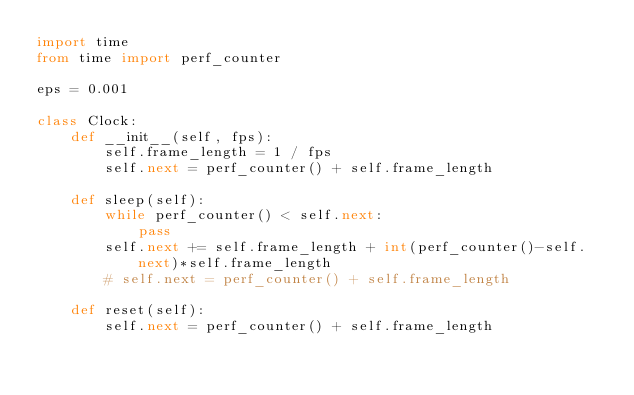Convert code to text. <code><loc_0><loc_0><loc_500><loc_500><_Python_>import time
from time import perf_counter

eps = 0.001

class Clock:
    def __init__(self, fps):
        self.frame_length = 1 / fps
        self.next = perf_counter() + self.frame_length

    def sleep(self):
        while perf_counter() < self.next:
            pass
        self.next += self.frame_length + int(perf_counter()-self.next)*self.frame_length
        # self.next = perf_counter() + self.frame_length

    def reset(self):
        self.next = perf_counter() + self.frame_length
</code> 